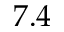Convert formula to latex. <formula><loc_0><loc_0><loc_500><loc_500>7 . 4</formula> 